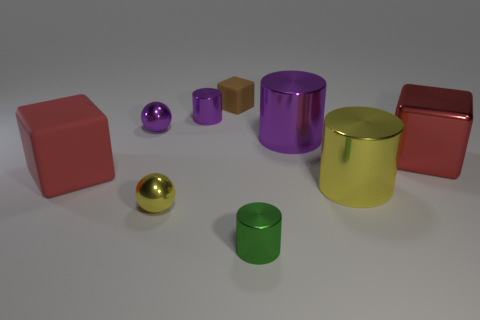Subtract all purple cylinders. How many red blocks are left? 2 Add 1 tiny yellow cylinders. How many objects exist? 10 Subtract all gray cylinders. Subtract all green cubes. How many cylinders are left? 4 Subtract all balls. How many objects are left? 7 Add 5 tiny yellow objects. How many tiny yellow objects are left? 6 Add 2 red metallic balls. How many red metallic balls exist? 2 Subtract 0 blue cylinders. How many objects are left? 9 Subtract all big red metallic things. Subtract all large purple metallic things. How many objects are left? 7 